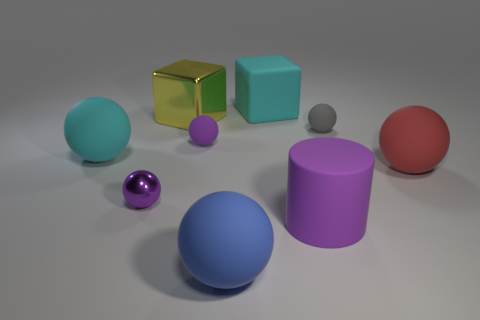Subtract all gray spheres. How many spheres are left? 5 Subtract all gray matte spheres. How many spheres are left? 5 Subtract all green balls. Subtract all gray cubes. How many balls are left? 6 Subtract all cylinders. How many objects are left? 8 Add 3 large cyan matte cubes. How many large cyan matte cubes exist? 4 Subtract 0 brown balls. How many objects are left? 9 Subtract all brown shiny spheres. Subtract all big cyan rubber balls. How many objects are left? 8 Add 6 large cyan balls. How many large cyan balls are left? 7 